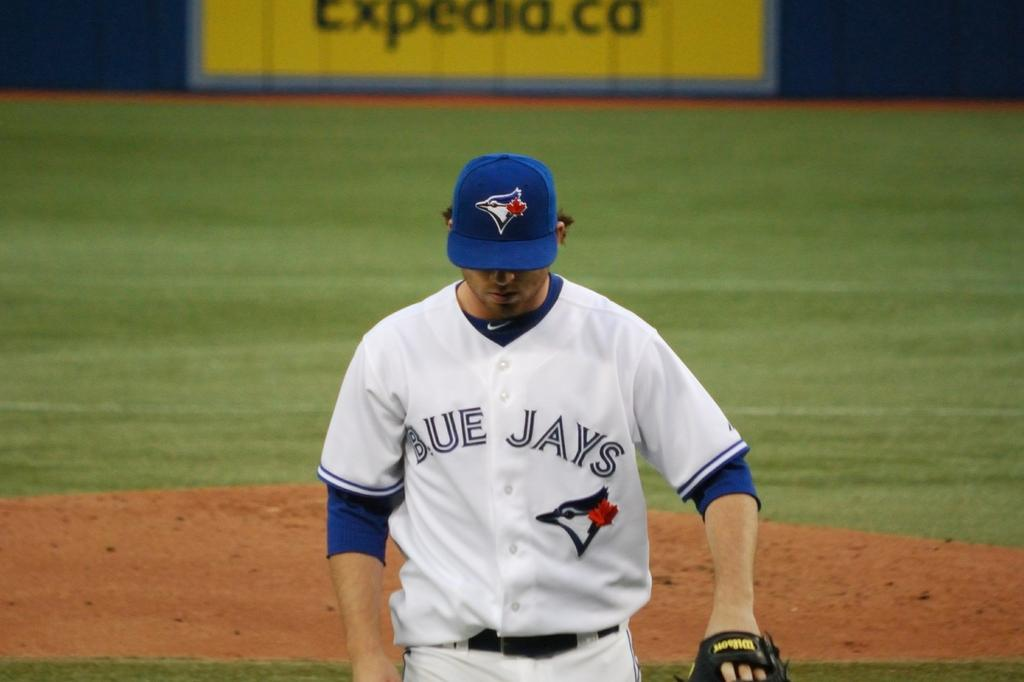<image>
Provide a brief description of the given image. A pitcher for the Blue Jays is standing on the pitcher's mound. 